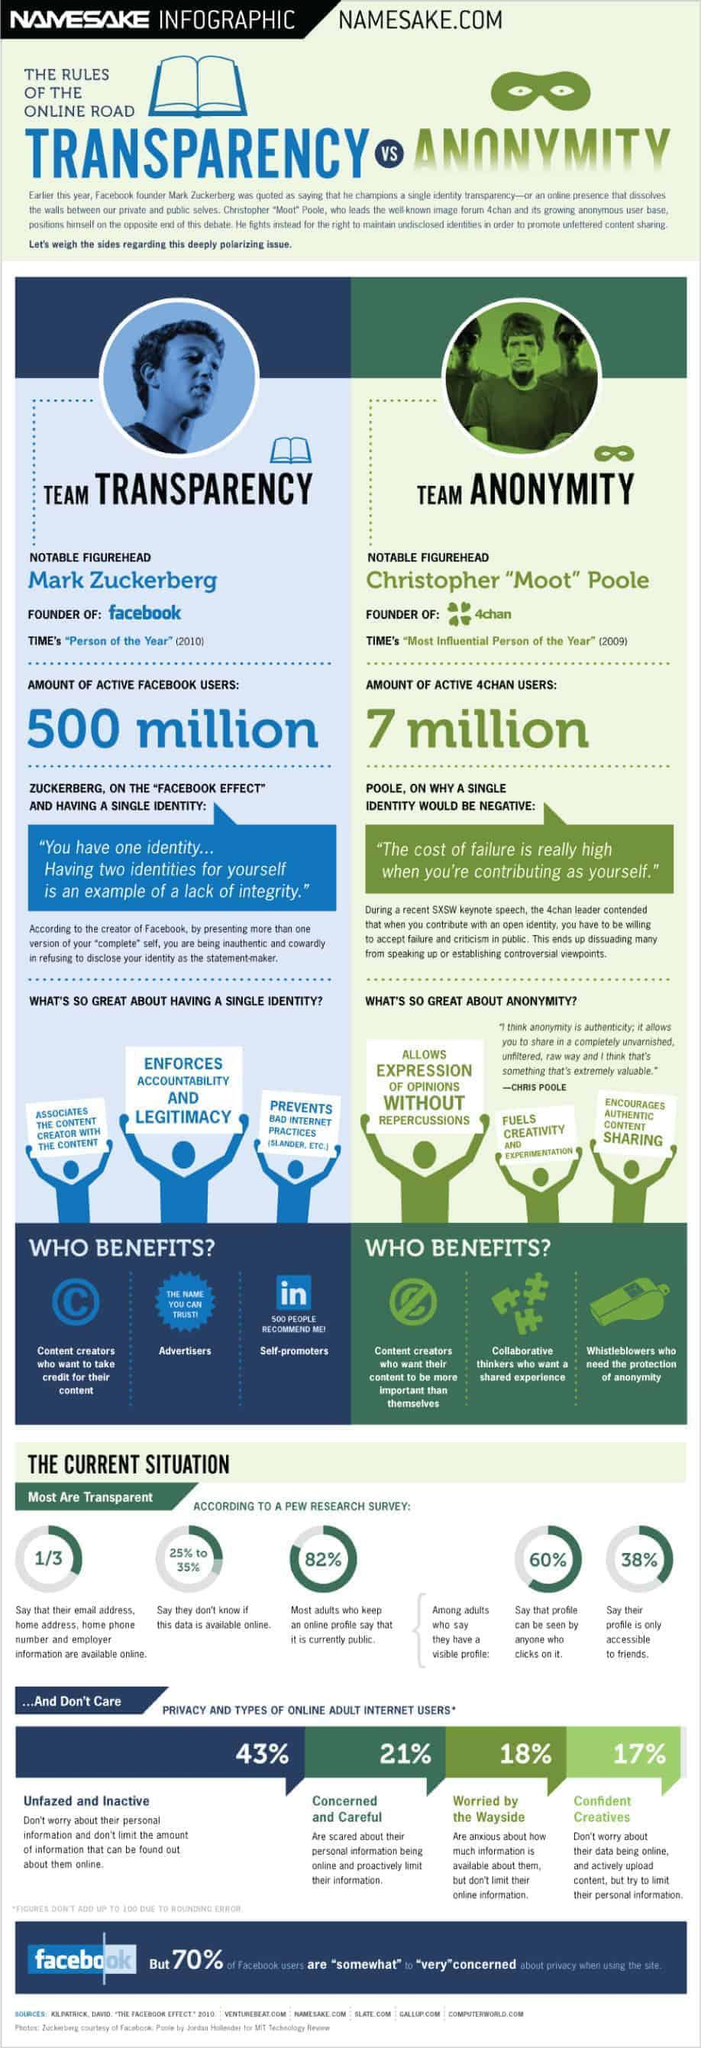What percent of adults do not have public profile?
Answer the question with a short phrase. 18% Which two prominent people are mentioned? Mark Zuckerberg, Christopher "Moot" Pole Which type of internet users form the second highest in terms of privacy and usage? Concerned and Careful According to Zuckerberg who are benefitted by transparency and single identity? Content creators, Advertisers, Self-promoters What percent of Facebook users are not concerned about privacy when using the site? 30% 